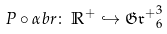<formula> <loc_0><loc_0><loc_500><loc_500>P \circ { \alpha b r } \colon \, { \mathbb { R } } ^ { + } \hookrightarrow { \mathfrak { G r ^ { + } } } ^ { 3 } _ { 6 }</formula> 